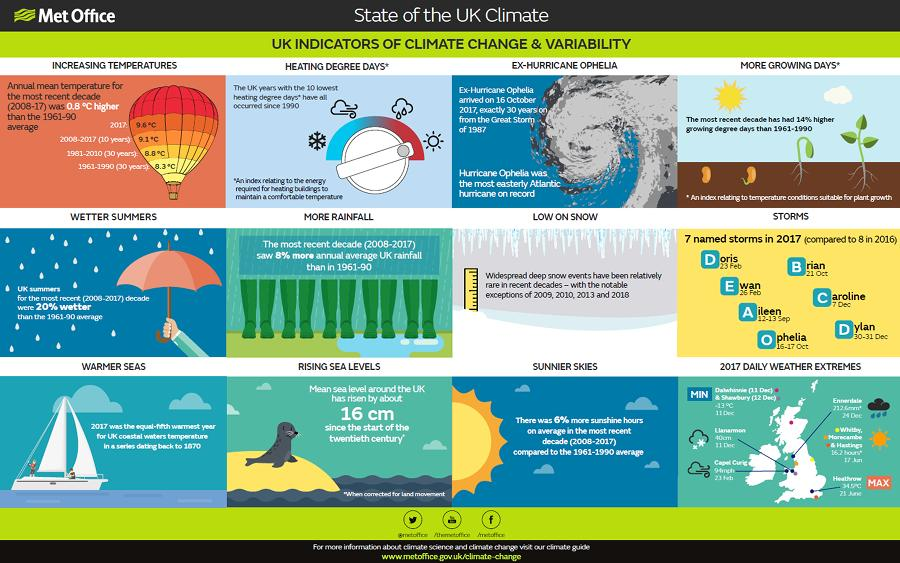Give some essential details in this illustration. The storm named "Brian" occurred in the UK on October 21, 2017. On October 16, 2017, the ex-hurricane Ophelia occurred in the United Kingdom. On the 30th and 31st of December, a severe storm called Dylan occurred in the United Kingdom. 